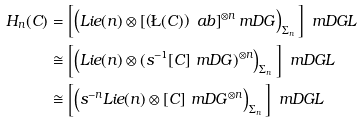<formula> <loc_0><loc_0><loc_500><loc_500>H _ { n } ( C ) & = \left [ \left ( L i e ( n ) \otimes \left [ \left ( \L ( C ) \right ) ^ { \ } a b \right ] ^ { \otimes n } _ { \ } m D G \right ) _ { \Sigma _ { n } } \, \right ] _ { \ } m D G L \\ & \cong \left [ \left ( L i e ( n ) \otimes ( s ^ { - 1 } [ C ] _ { \ } m D G ) ^ { \otimes n } \right ) _ { \Sigma _ { n } } \, \right ] _ { \ } m D G L \\ & \cong \left [ \left ( s ^ { - n } L i e ( n ) \otimes [ C ] _ { \ } m D G ^ { \otimes n } \right ) _ { \Sigma _ { n } } \, \right ] _ { \ } m D G L</formula> 